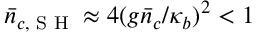Convert formula to latex. <formula><loc_0><loc_0><loc_500><loc_500>\bar { n } _ { c , S H } \approx 4 ( g \bar { n } _ { c } / \kappa _ { b } ) ^ { 2 } < 1</formula> 